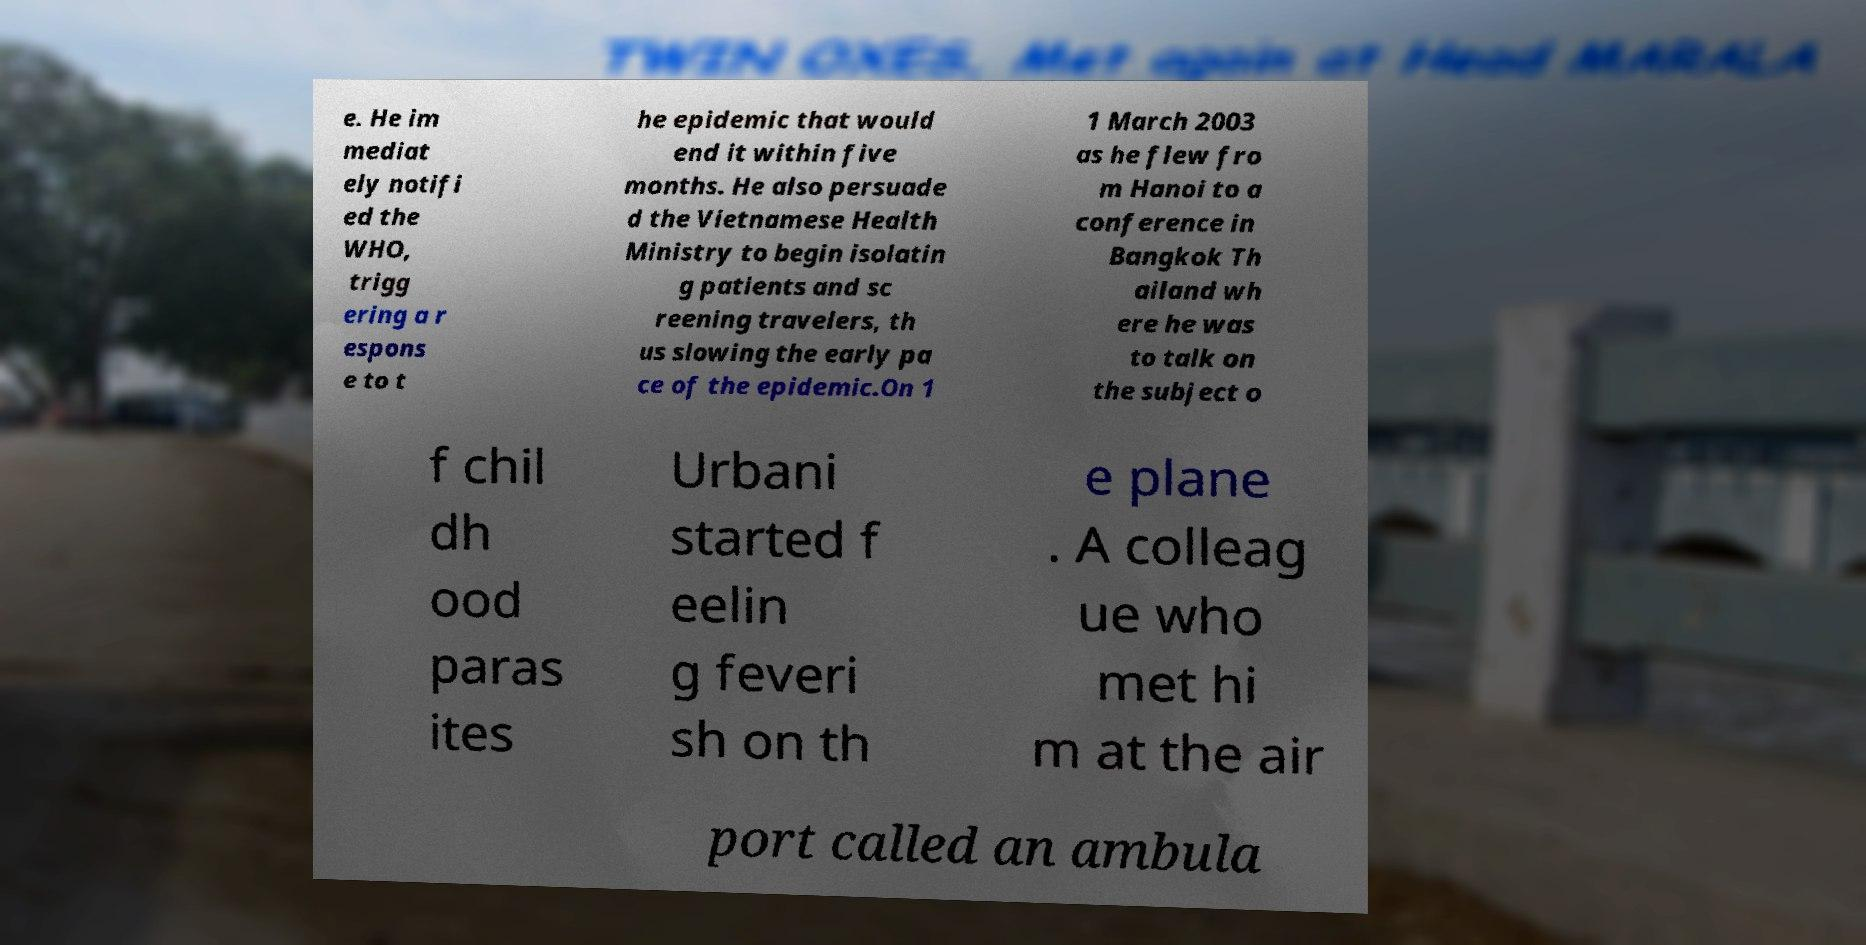Can you accurately transcribe the text from the provided image for me? e. He im mediat ely notifi ed the WHO, trigg ering a r espons e to t he epidemic that would end it within five months. He also persuade d the Vietnamese Health Ministry to begin isolatin g patients and sc reening travelers, th us slowing the early pa ce of the epidemic.On 1 1 March 2003 as he flew fro m Hanoi to a conference in Bangkok Th ailand wh ere he was to talk on the subject o f chil dh ood paras ites Urbani started f eelin g feveri sh on th e plane . A colleag ue who met hi m at the air port called an ambula 